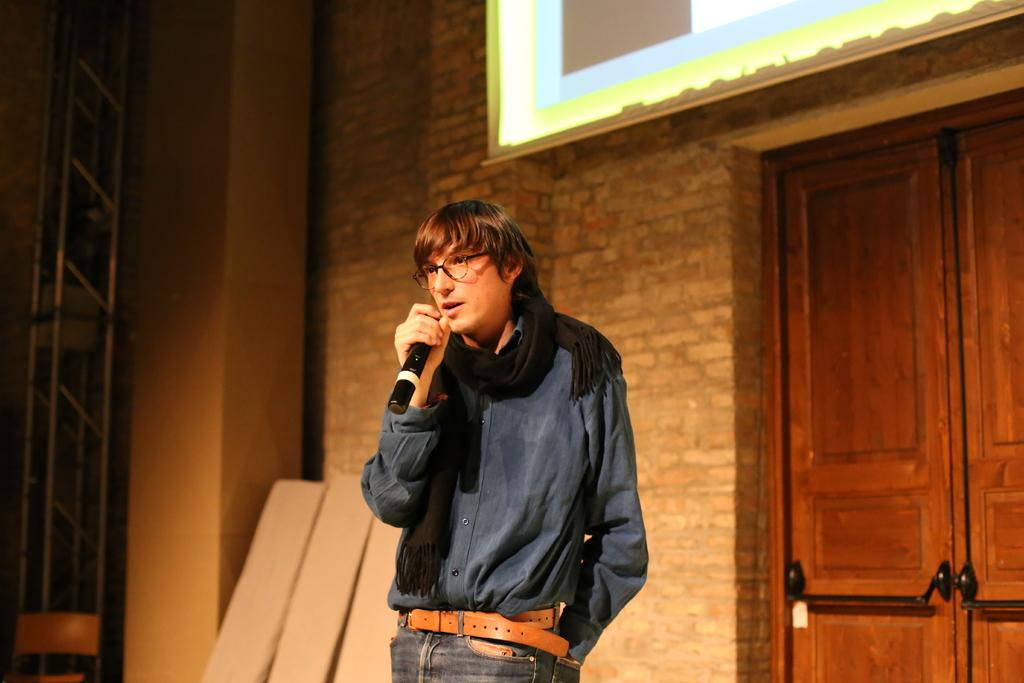What is the main subject of the image? There is a person in the image. What is the person doing in the image? The person is standing and speaking. What object is the person holding in the image? The person is holding a microphone. What can be seen in the background of the image? There is a door visible in the background. What is located at the top of the image? There is a projector screen at the top of the image. What type of smell can be detected in the image? There is no mention of any smell in the image, so it cannot be determined from the image. 